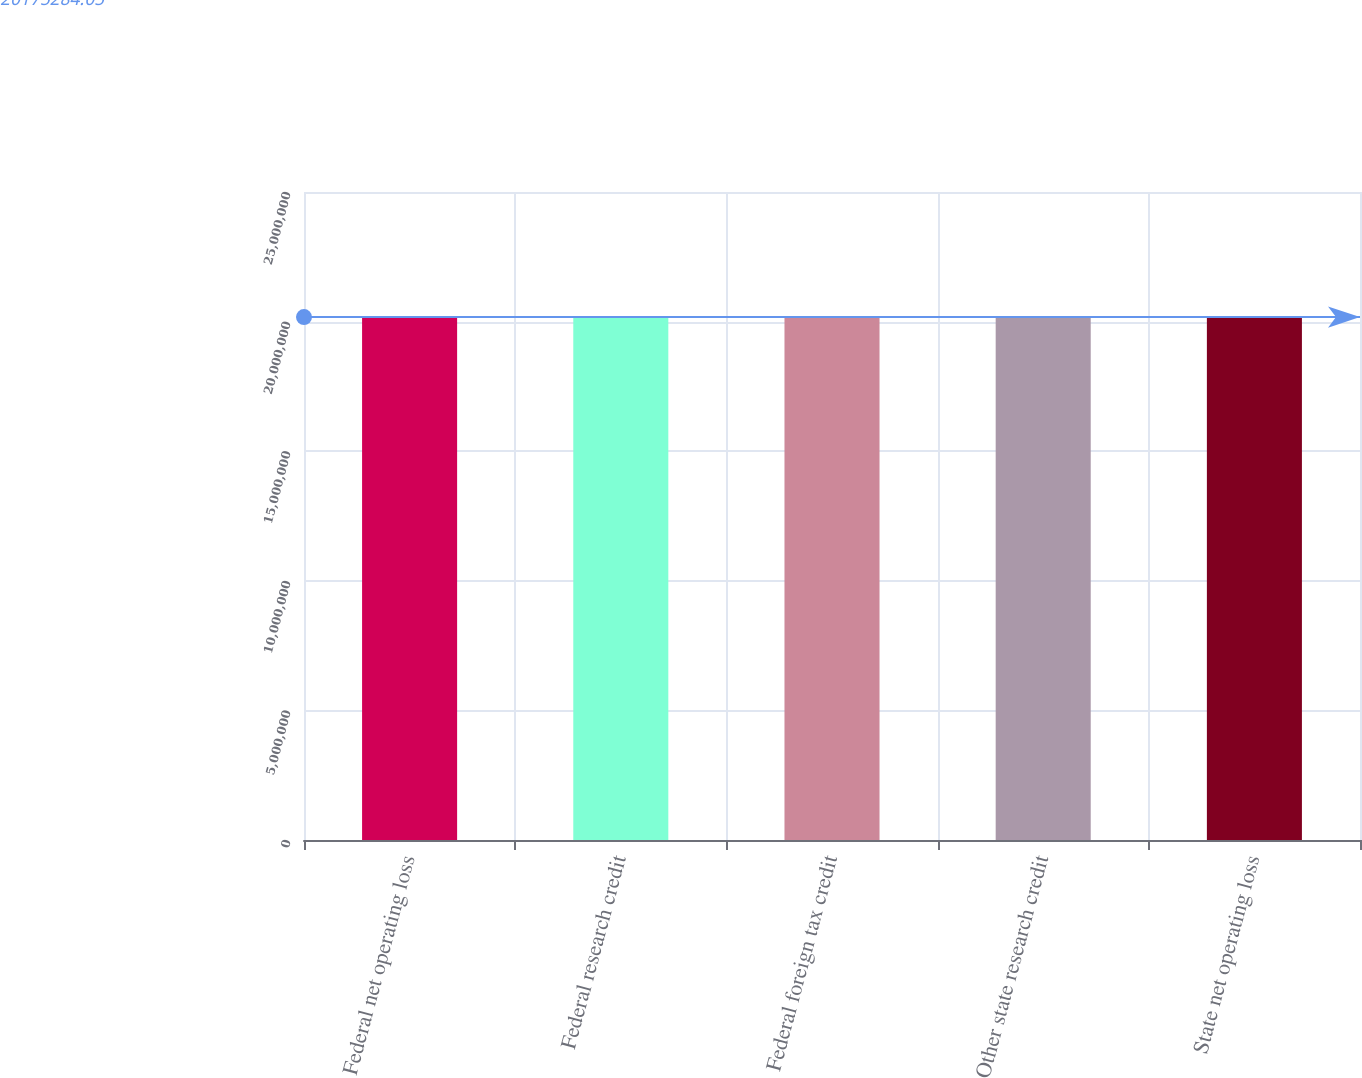Convert chart. <chart><loc_0><loc_0><loc_500><loc_500><bar_chart><fcel>Federal net operating loss<fcel>Federal research credit<fcel>Federal foreign tax credit<fcel>Other state research credit<fcel>State net operating loss<nl><fcel>2.0182e+07<fcel>2.0194e+07<fcel>2.0192e+07<fcel>2.0172e+07<fcel>2.0174e+07<nl></chart> 